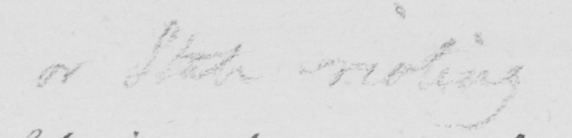What is written in this line of handwriting? or State rioting 